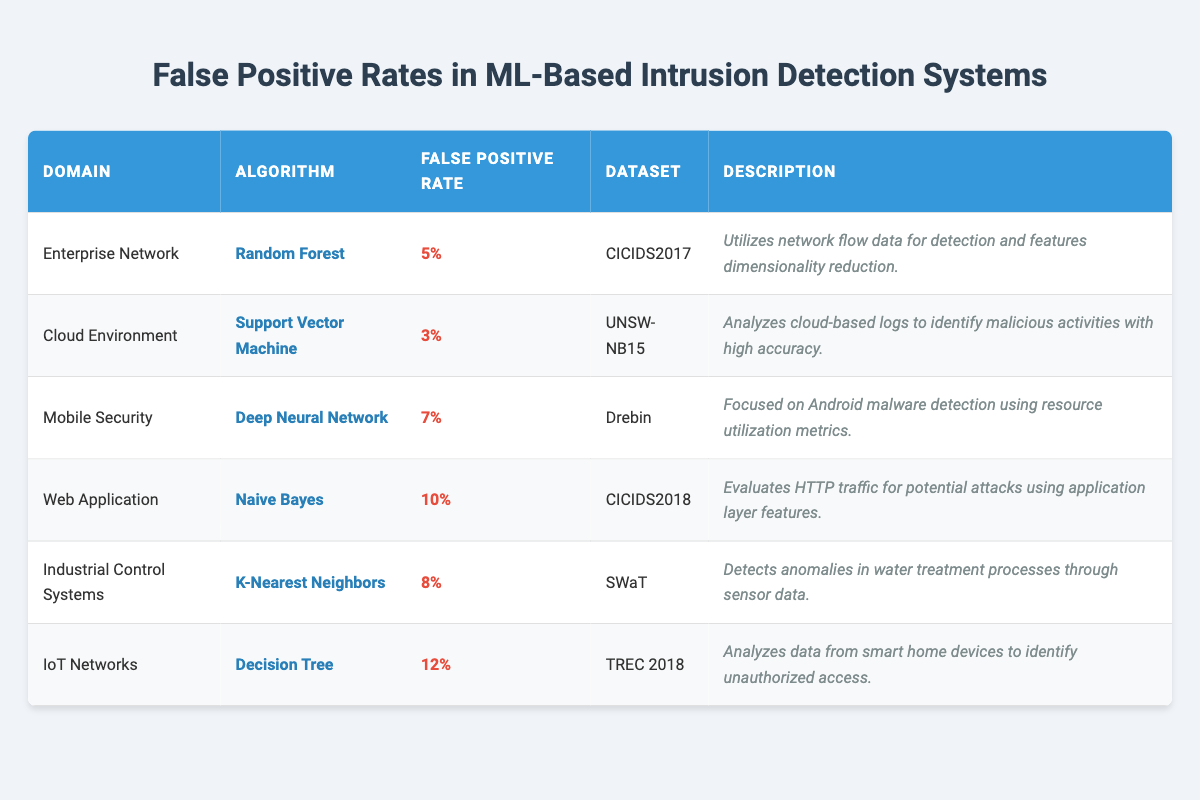What is the false positive rate for the Support Vector Machine in the Cloud Environment? The table shows the specific row for the Cloud Environment where the algorithm is Support Vector Machine, and the corresponding false positive rate is 3%.
Answer: 3% Which algorithm has the highest false positive rate? By examining the table, the algorithm with the highest false positive rate is Decision Tree in the IoT Networks domain, which has a rate of 12%.
Answer: Decision Tree What are the domains listed in the table with their respective false positive rates? The domains and their false positive rates are as follows: Enterprise Network (5%), Cloud Environment (3%), Mobile Security (7%), Web Application (10%), Industrial Control Systems (8%), and IoT Networks (12%).
Answer: Enterprise Network 5%, Cloud Environment 3%, Mobile Security 7%, Web Application 10%, Industrial Control Systems 8%, IoT Networks 12% Is the false positive rate for the Deep Neural Network higher than that for the Naive Bayes algorithm? The false positive rate for the Deep Neural Network is 7%, while for Naive Bayes, it is 10%. Since 7% is not greater than 10%, the statement is false.
Answer: No What is the average false positive rate across all algorithms listed in the table? To find the average, we calculate the sum of all false positive rates: 5% + 3% + 7% + 10% + 8% + 12% = 45%. Then, we divide by the number of algorithms, which is 6: 45% / 6 = 7.5%.
Answer: 7.5% Which dataset has the lowest false positive rate, and what is the rate? By checking each row in the table, the dataset with the lowest false positive rate is UNSW-NB15, associated with the Support Vector Machine, which has a rate of 3%.
Answer: UNSW-NB15, 3% Are there more algorithms with a false positive rate above 8% than below? There are three algorithms with a false positive rate above 8% (Naive Bayes, K-Nearest Neighbors, and Decision Tree) and three below (Random Forest, Support Vector Machine, and Deep Neural Network). Since they are equal, the answer is no.
Answer: No What is the difference in false positive rates between the IoT Networks and the Cloud Environment? The false positive rate for IoT Networks is 12% and for Cloud Environment is 3%. The difference is calculated as 12% - 3% = 9%.
Answer: 9% In which domain is the K-Nearest Neighbors algorithm used? The table specifies that K-Nearest Neighbors is used in the Industrial Control Systems domain.
Answer: Industrial Control Systems 